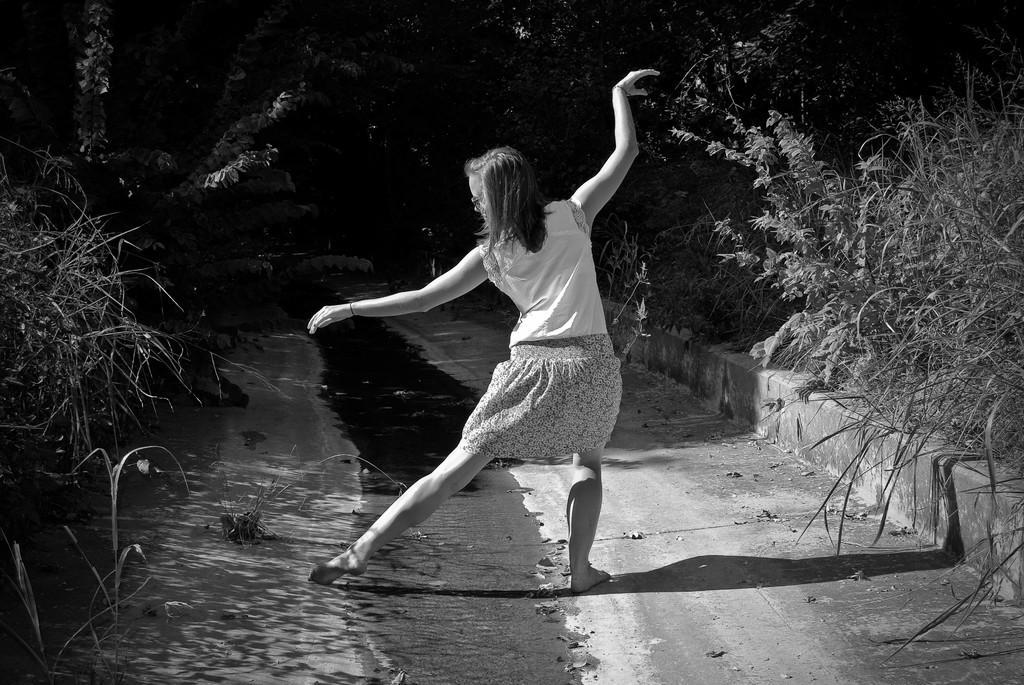In one or two sentences, can you explain what this image depicts? In this picture I can observe a woman dancing in this path. On either sides of this path they can observe some plants and trees. This is a black and white image. 